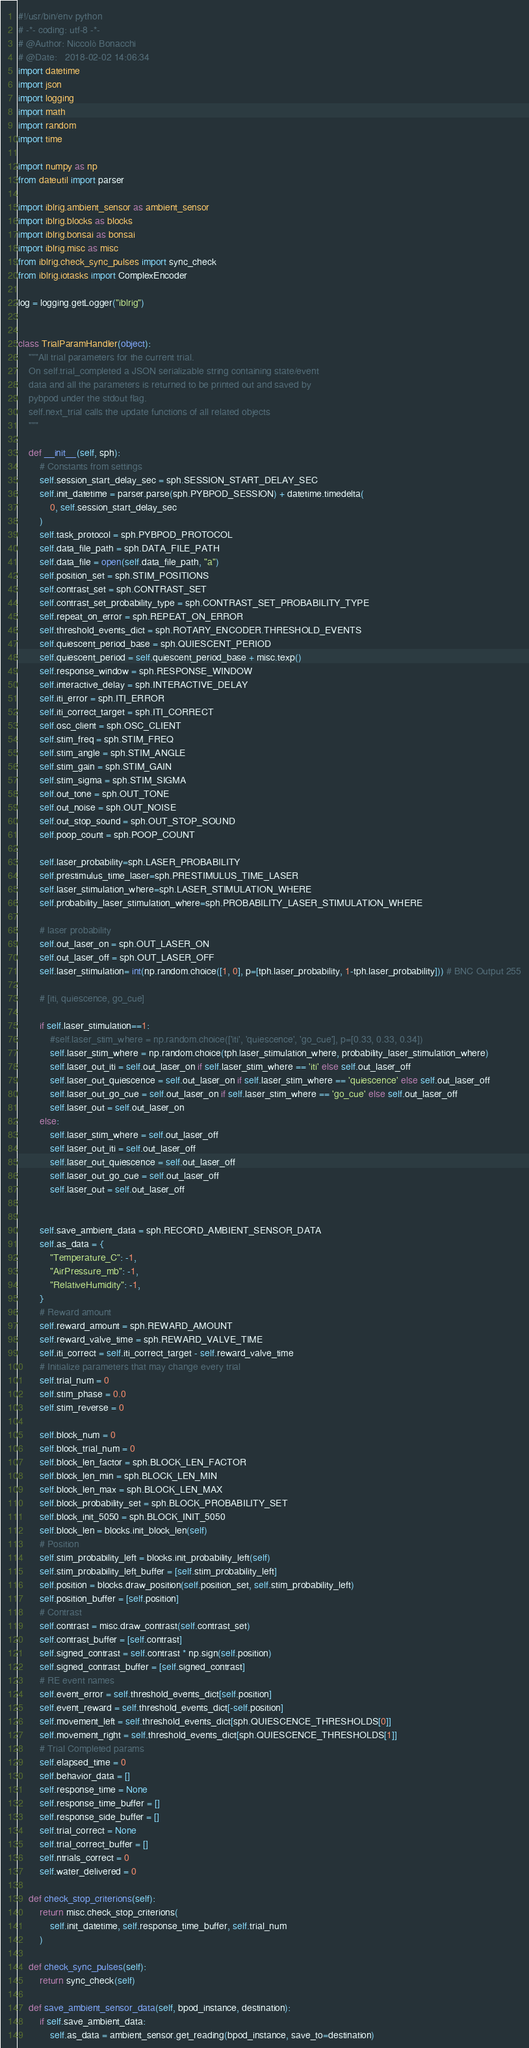<code> <loc_0><loc_0><loc_500><loc_500><_Python_>#!/usr/bin/env python
# -*- coding: utf-8 -*-
# @Author: Niccolò Bonacchi
# @Date:   2018-02-02 14:06:34
import datetime
import json
import logging
import math
import random
import time

import numpy as np
from dateutil import parser

import iblrig.ambient_sensor as ambient_sensor
import iblrig.blocks as blocks
import iblrig.bonsai as bonsai
import iblrig.misc as misc
from iblrig.check_sync_pulses import sync_check
from iblrig.iotasks import ComplexEncoder

log = logging.getLogger("iblrig")


class TrialParamHandler(object):
    """All trial parameters for the current trial.
    On self.trial_completed a JSON serializable string containing state/event
    data and all the parameters is returned to be printed out and saved by
    pybpod under the stdout flag.
    self.next_trial calls the update functions of all related objects
    """

    def __init__(self, sph):
        # Constants from settings
        self.session_start_delay_sec = sph.SESSION_START_DELAY_SEC
        self.init_datetime = parser.parse(sph.PYBPOD_SESSION) + datetime.timedelta(
            0, self.session_start_delay_sec
        )
        self.task_protocol = sph.PYBPOD_PROTOCOL
        self.data_file_path = sph.DATA_FILE_PATH
        self.data_file = open(self.data_file_path, "a")
        self.position_set = sph.STIM_POSITIONS
        self.contrast_set = sph.CONTRAST_SET
        self.contrast_set_probability_type = sph.CONTRAST_SET_PROBABILITY_TYPE
        self.repeat_on_error = sph.REPEAT_ON_ERROR
        self.threshold_events_dict = sph.ROTARY_ENCODER.THRESHOLD_EVENTS
        self.quiescent_period_base = sph.QUIESCENT_PERIOD
        self.quiescent_period = self.quiescent_period_base + misc.texp()
        self.response_window = sph.RESPONSE_WINDOW
        self.interactive_delay = sph.INTERACTIVE_DELAY
        self.iti_error = sph.ITI_ERROR
        self.iti_correct_target = sph.ITI_CORRECT
        self.osc_client = sph.OSC_CLIENT
        self.stim_freq = sph.STIM_FREQ
        self.stim_angle = sph.STIM_ANGLE
        self.stim_gain = sph.STIM_GAIN
        self.stim_sigma = sph.STIM_SIGMA
        self.out_tone = sph.OUT_TONE
        self.out_noise = sph.OUT_NOISE
        self.out_stop_sound = sph.OUT_STOP_SOUND
        self.poop_count = sph.POOP_COUNT

        self.laser_probability=sph.LASER_PROBABILITY
        self.prestimulus_time_laser=sph.PRESTIMULUS_TIME_LASER
        self.laser_stimulation_where=sph.LASER_STIMULATION_WHERE
        self.probability_laser_stimulation_where=sph.PROBABILITY_LASER_STIMULATION_WHERE

        # laser probability
        self.out_laser_on = sph.OUT_LASER_ON
        self.out_laser_off = sph.OUT_LASER_OFF
        self.laser_stimulation= int(np.random.choice([1, 0], p=[tph.laser_probability, 1-tph.laser_probability])) # BNC Output 255

        # [iti, quiescence, go_cue]

        if self.laser_stimulation==1:
            #self.laser_stim_where = np.random.choice(['iti', 'quiescence', 'go_cue'], p=[0.33, 0.33, 0.34])
            self.laser_stim_where = np.random.choice(tph.laser_stimulation_where, probability_laser_stimulation_where)
            self.laser_out_iti = self.out_laser_on if self.laser_stim_where == 'iti' else self.out_laser_off
            self.laser_out_quiescence = self.out_laser_on if self.laser_stim_where == 'quiescence' else self.out_laser_off
            self.laser_out_go_cue = self.out_laser_on if self.laser_stim_where == 'go_cue' else self.out_laser_off
            self.laser_out = self.out_laser_on
        else:
            self.laser_stim_where = self.out_laser_off
            self.laser_out_iti = self.out_laser_off
            self.laser_out_quiescence = self.out_laser_off
            self.laser_out_go_cue = self.out_laser_off
            self.laser_out = self.out_laser_off


        self.save_ambient_data = sph.RECORD_AMBIENT_SENSOR_DATA
        self.as_data = {
            "Temperature_C": -1,
            "AirPressure_mb": -1,
            "RelativeHumidity": -1,
        }
        # Reward amount
        self.reward_amount = sph.REWARD_AMOUNT
        self.reward_valve_time = sph.REWARD_VALVE_TIME
        self.iti_correct = self.iti_correct_target - self.reward_valve_time
        # Initialize parameters that may change every trial
        self.trial_num = 0
        self.stim_phase = 0.0
        self.stim_reverse = 0

        self.block_num = 0
        self.block_trial_num = 0
        self.block_len_factor = sph.BLOCK_LEN_FACTOR
        self.block_len_min = sph.BLOCK_LEN_MIN
        self.block_len_max = sph.BLOCK_LEN_MAX
        self.block_probability_set = sph.BLOCK_PROBABILITY_SET
        self.block_init_5050 = sph.BLOCK_INIT_5050
        self.block_len = blocks.init_block_len(self)
        # Position
        self.stim_probability_left = blocks.init_probability_left(self)
        self.stim_probability_left_buffer = [self.stim_probability_left]
        self.position = blocks.draw_position(self.position_set, self.stim_probability_left)
        self.position_buffer = [self.position]
        # Contrast
        self.contrast = misc.draw_contrast(self.contrast_set)
        self.contrast_buffer = [self.contrast]
        self.signed_contrast = self.contrast * np.sign(self.position)
        self.signed_contrast_buffer = [self.signed_contrast]
        # RE event names
        self.event_error = self.threshold_events_dict[self.position]
        self.event_reward = self.threshold_events_dict[-self.position]
        self.movement_left = self.threshold_events_dict[sph.QUIESCENCE_THRESHOLDS[0]]
        self.movement_right = self.threshold_events_dict[sph.QUIESCENCE_THRESHOLDS[1]]
        # Trial Completed params
        self.elapsed_time = 0
        self.behavior_data = []
        self.response_time = None
        self.response_time_buffer = []
        self.response_side_buffer = []
        self.trial_correct = None
        self.trial_correct_buffer = []
        self.ntrials_correct = 0
        self.water_delivered = 0

    def check_stop_criterions(self):
        return misc.check_stop_criterions(
            self.init_datetime, self.response_time_buffer, self.trial_num
        )

    def check_sync_pulses(self):
        return sync_check(self)

    def save_ambient_sensor_data(self, bpod_instance, destination):
        if self.save_ambient_data:
            self.as_data = ambient_sensor.get_reading(bpod_instance, save_to=destination)</code> 